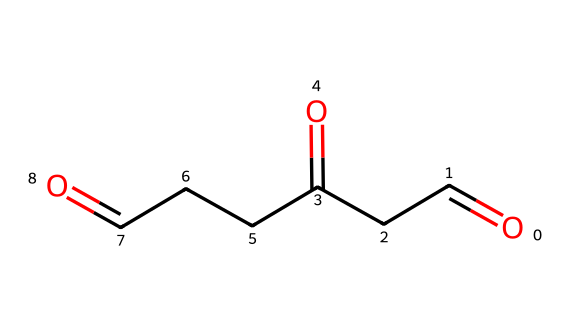What is the molecular formula of glutaraldehyde? To identify the molecular formula, count the number of each type of atom in the structure represented by the SMILES string. It has five carbon (C) atoms, eight hydrogen (H) atoms, and two oxygen (O) atoms. Thus, the molecular formula is C5H8O2.
Answer: C5H8O2 How many carbon atoms are present in glutaraldehyde? By examining the SMILES representation, we can observe that there are five distinct carbon atoms, evident from the structure which shows the chain and branching.
Answer: 5 What type of functional groups are present in this chemical? The SMILES notation indicates the presence of aldehyde groups at both ends of the carbon chain. The carbonyl groups (C=O) are representative of aldehydes, which are characterized by a carbon atom double bonded to an oxygen atom and single bonded to a hydrogen atom.
Answer: aldehyde Is glutaraldehyde a saturated or unsaturated compound? By noting the presence of double bonds in the structure (C=C), we can determine that glutaraldehyde contains unsaturation due to its carbon-carbon double bonds. Therefore, it is classified as an unsaturated compound.
Answer: unsaturated What is one primary use of glutaraldehyde in a medical context? Glutaraldehyde is primarily used as a disinfectant and sterilizing agent for medical equipment due to its efficacy in killing bacteria and viruses. This underscores its critical role in maintaining hygiene standards in medical facilities.
Answer: disinfectant Why is glutaraldehyde considered a hazardous chemical? Recognizing its potential health hazards, glutaraldehyde can cause irritation to the skin and respiratory tract, along with more severe effects upon prolonged exposure. Such hazards necessitate careful handling and personal protective equipment during its use.
Answer: irritant 